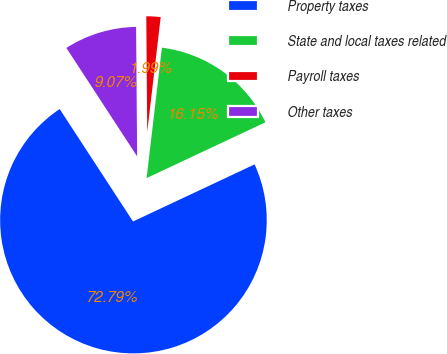Convert chart to OTSL. <chart><loc_0><loc_0><loc_500><loc_500><pie_chart><fcel>Property taxes<fcel>State and local taxes related<fcel>Payroll taxes<fcel>Other taxes<nl><fcel>72.78%<fcel>16.15%<fcel>1.99%<fcel>9.07%<nl></chart> 